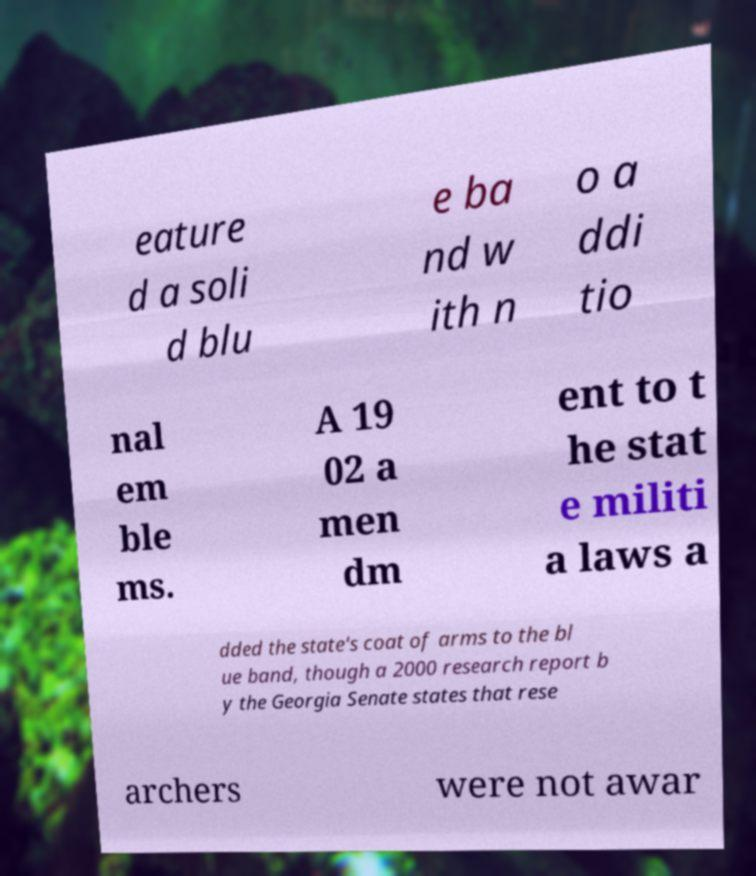There's text embedded in this image that I need extracted. Can you transcribe it verbatim? eature d a soli d blu e ba nd w ith n o a ddi tio nal em ble ms. A 19 02 a men dm ent to t he stat e militi a laws a dded the state's coat of arms to the bl ue band, though a 2000 research report b y the Georgia Senate states that rese archers were not awar 